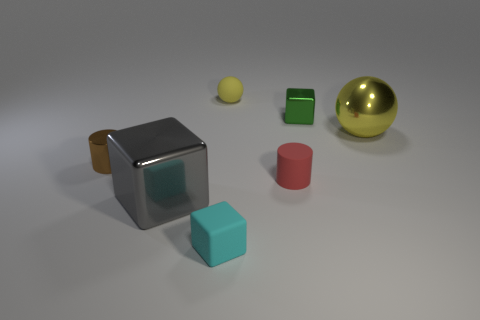Is there a metallic block of the same size as the brown object?
Your answer should be compact. Yes. There is a tiny cylinder on the right side of the small ball; is it the same color as the tiny sphere?
Your answer should be compact. No. How many purple things are either matte balls or small cylinders?
Your answer should be compact. 0. What number of things are the same color as the metal sphere?
Your answer should be very brief. 1. Is the brown cylinder made of the same material as the big sphere?
Make the answer very short. Yes. There is a small metallic object that is behind the brown metallic thing; how many large metallic spheres are to the right of it?
Ensure brevity in your answer.  1. Does the cyan matte object have the same size as the yellow shiny thing?
Your answer should be compact. No. What number of small cyan cubes are made of the same material as the tiny red thing?
Your response must be concise. 1. There is a green metallic thing that is the same shape as the tiny cyan rubber object; what size is it?
Offer a very short reply. Small. Do the large metallic thing in front of the tiny brown shiny cylinder and the small cyan matte object have the same shape?
Provide a succinct answer. Yes. 